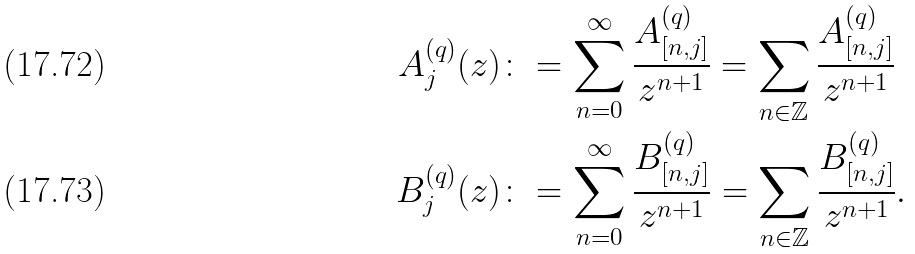<formula> <loc_0><loc_0><loc_500><loc_500>A _ { j } ^ { ( q ) } ( z ) & \colon = \sum _ { n = 0 } ^ { \infty } \frac { A _ { [ n , j ] } ^ { ( q ) } } { z ^ { n + 1 } } = \sum _ { n \in \mathbb { Z } } \frac { A _ { [ n , j ] } ^ { ( q ) } } { z ^ { n + 1 } } \\ B _ { j } ^ { ( q ) } ( z ) & \colon = \sum _ { n = 0 } ^ { \infty } \frac { B _ { [ n , j ] } ^ { ( q ) } } { z ^ { n + 1 } } = \sum _ { n \in \mathbb { Z } } \frac { B _ { [ n , j ] } ^ { ( q ) } } { z ^ { n + 1 } } .</formula> 